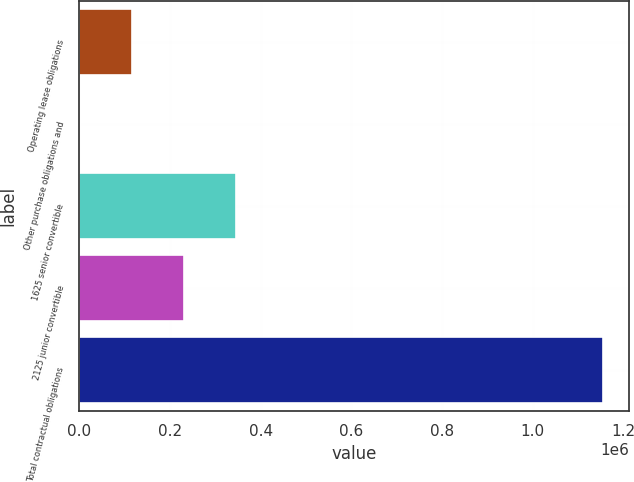<chart> <loc_0><loc_0><loc_500><loc_500><bar_chart><fcel>Operating lease obligations<fcel>Other purchase obligations and<fcel>1625 senior convertible<fcel>2125 junior convertible<fcel>Total contractual obligations<nl><fcel>115631<fcel>242<fcel>346408<fcel>231020<fcel>1.15413e+06<nl></chart> 